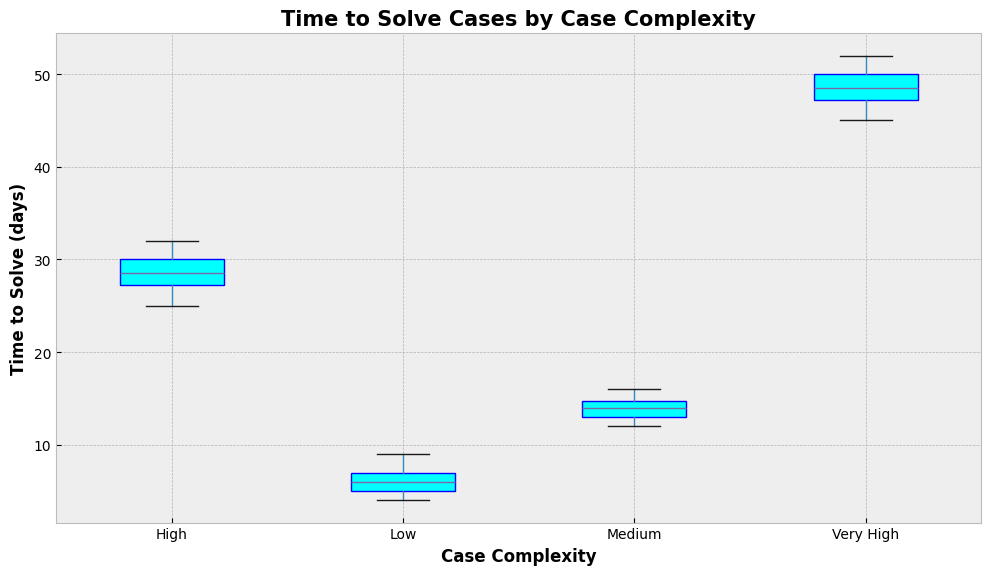What is the median time to solve cases for high complexity? Identify the high complexity box plot and locate the middle line inside the box, which represents the median time to solve cases.
Answer: 29 days What is the difference in the median time to solve cases between low and very high complexity? Locate the median lines inside the boxes for both low and very high complexity. The median for low complexity is 6 days and for very high complexity is 48 days. Subtract the low complexity median from the very high complexity median.
Answer: 42 days Which case complexity shows the widest range in time to solve cases? Compare the lengths of the whiskers (lines extending from the box) for each case complexity. The widest range will have the longest whiskers from the minimum to the maximum value.
Answer: Very High How does the upper quartile time to solve cases for medium complexity compare to the lower quartile time for high complexity? Locate the upper quartile (top edge of the box) for medium complexity, which is around 15 days, and the lower quartile (bottom edge of the box) for high complexity, which is around 26 days. Compare these values.
Answer: Medium complexity's upper quartile is less than high complexity's lower quartile Which case complexity has the smallest interquartile range (IQR) for time to solve cases? The IQR is the height of the box for each case complexity. Compare the heights of the boxes and find the smallest one.
Answer: Low What is the interquartile range for very high complexity cases? Identify the top and bottom edges of the box for very high complexity at roughly 50 and 47 days respectively. Subtract the lower quartile from the upper quartile to find the IQR.
Answer: 3 days Which complexity level shows the least variation in the time to solve cases based on box height and whisker length? Compare box heights and whisker lengths for all case complexities. The least variation will have the shortest box and whisker lengths.
Answer: Low What can you infer about the time to solve cases for medium complexity versus low complexity? Compare their respective boxes and whiskers on the plot. Medium complexity has a higher median and more evenly distributed whiskers, indicating it consistently takes longer to solve than low complexity.
Answer: Medium complexity takes longer Which case complexity appears to have the most consistently timed resolutions? Consistent timing is indicated by short whiskers and a compact box. Compare the lengths of the boxes and whiskers across all categories.
Answer: Low 